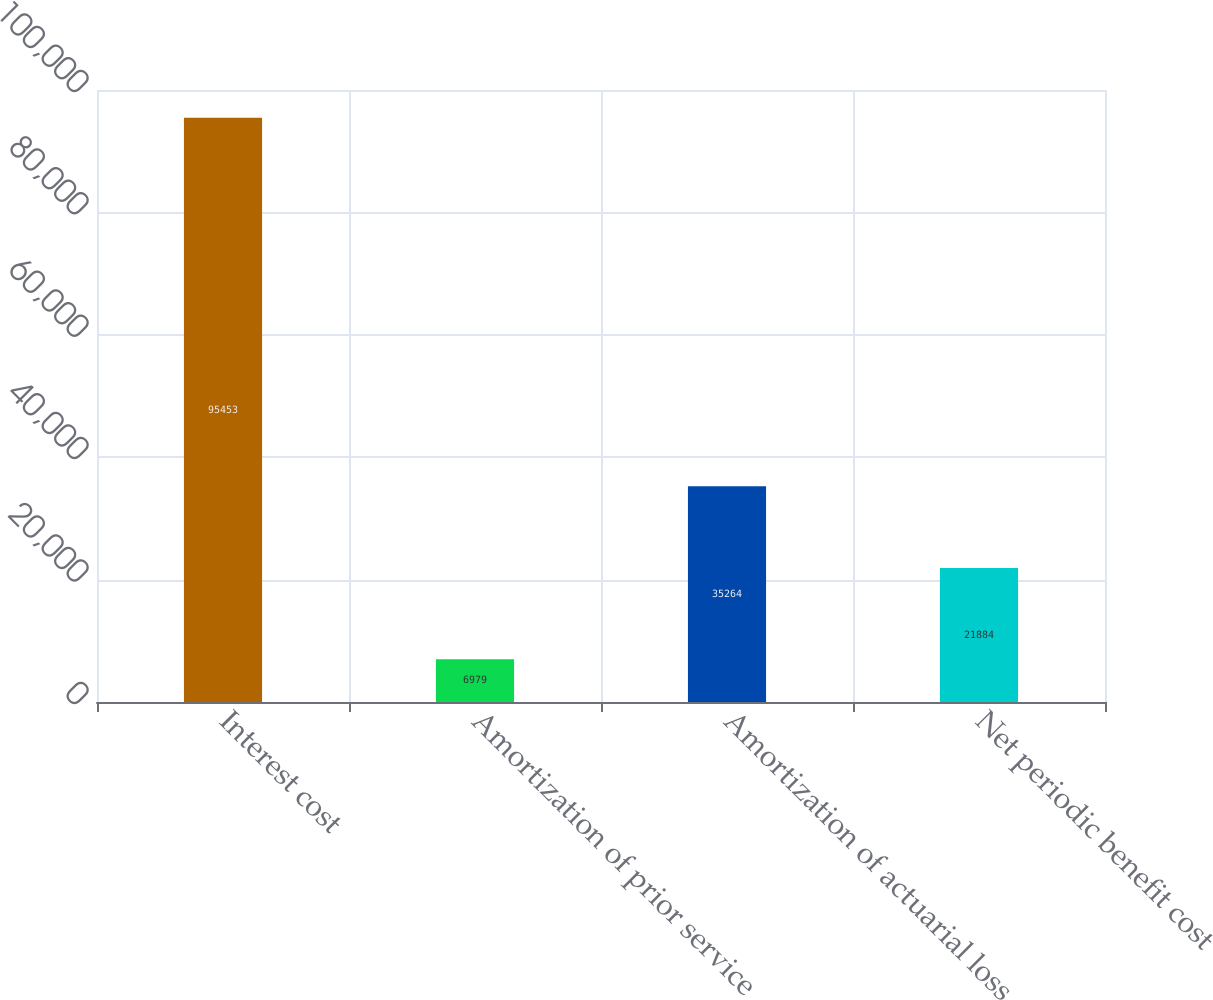Convert chart. <chart><loc_0><loc_0><loc_500><loc_500><bar_chart><fcel>Interest cost<fcel>Amortization of prior service<fcel>Amortization of actuarial loss<fcel>Net periodic benefit cost<nl><fcel>95453<fcel>6979<fcel>35264<fcel>21884<nl></chart> 